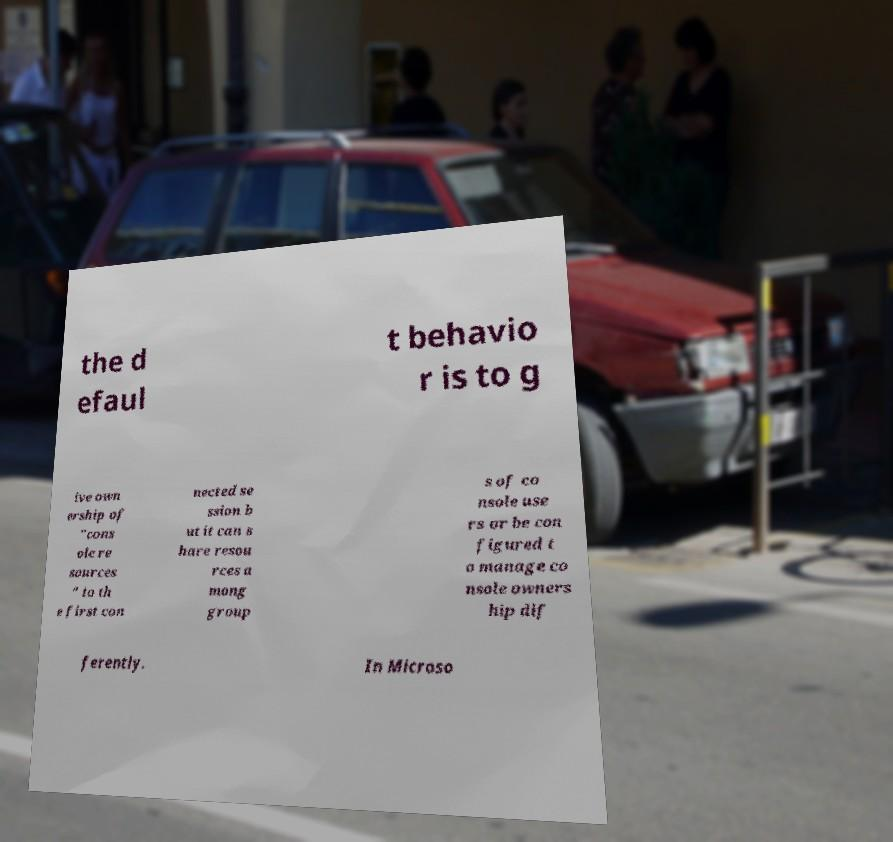Please identify and transcribe the text found in this image. the d efaul t behavio r is to g ive own ership of "cons ole re sources " to th e first con nected se ssion b ut it can s hare resou rces a mong group s of co nsole use rs or be con figured t o manage co nsole owners hip dif ferently. In Microso 